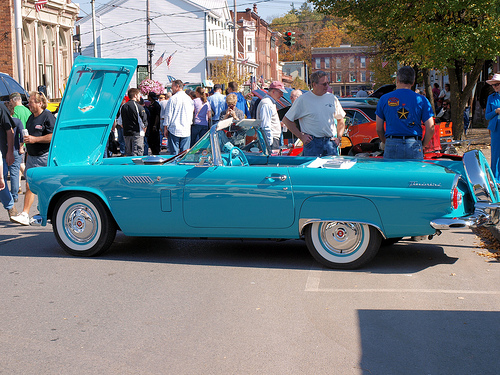<image>
Is the man in the car? No. The man is not contained within the car. These objects have a different spatial relationship. 